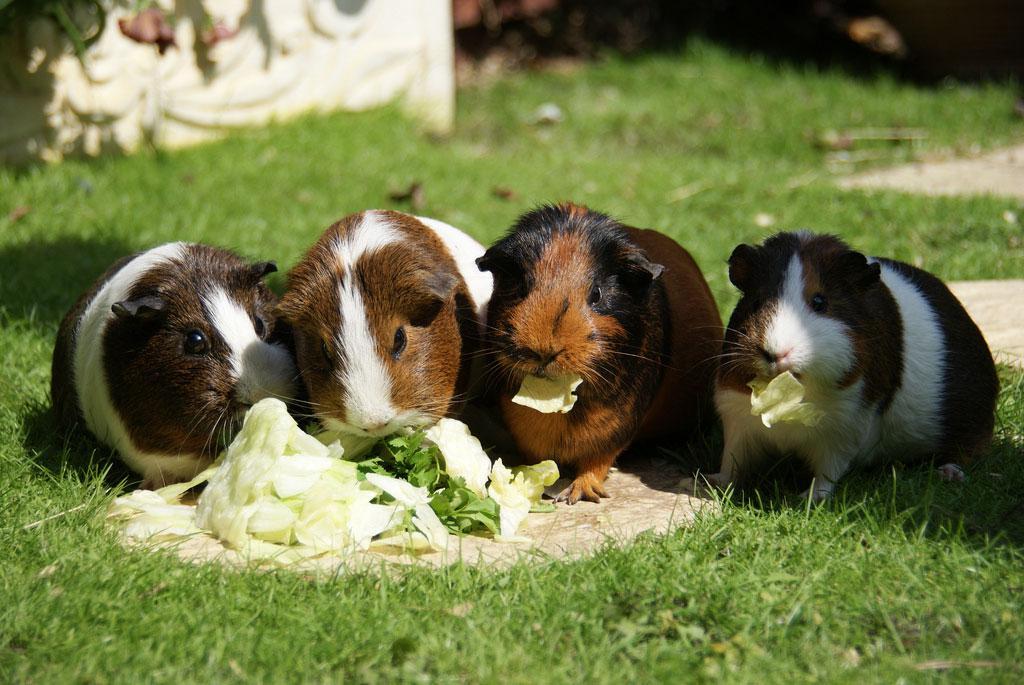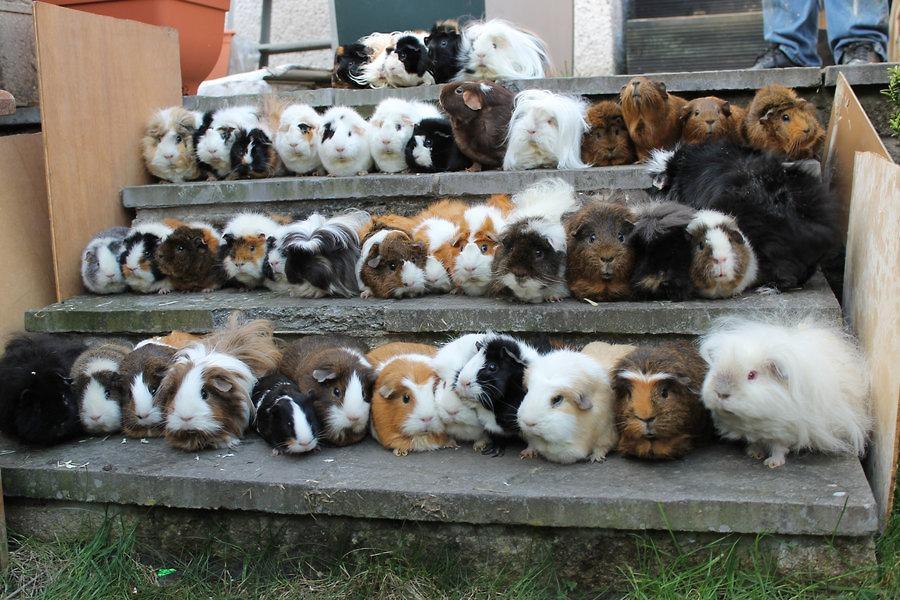The first image is the image on the left, the second image is the image on the right. Assess this claim about the two images: "There is a bowl in the image on the right.". Correct or not? Answer yes or no. No. 